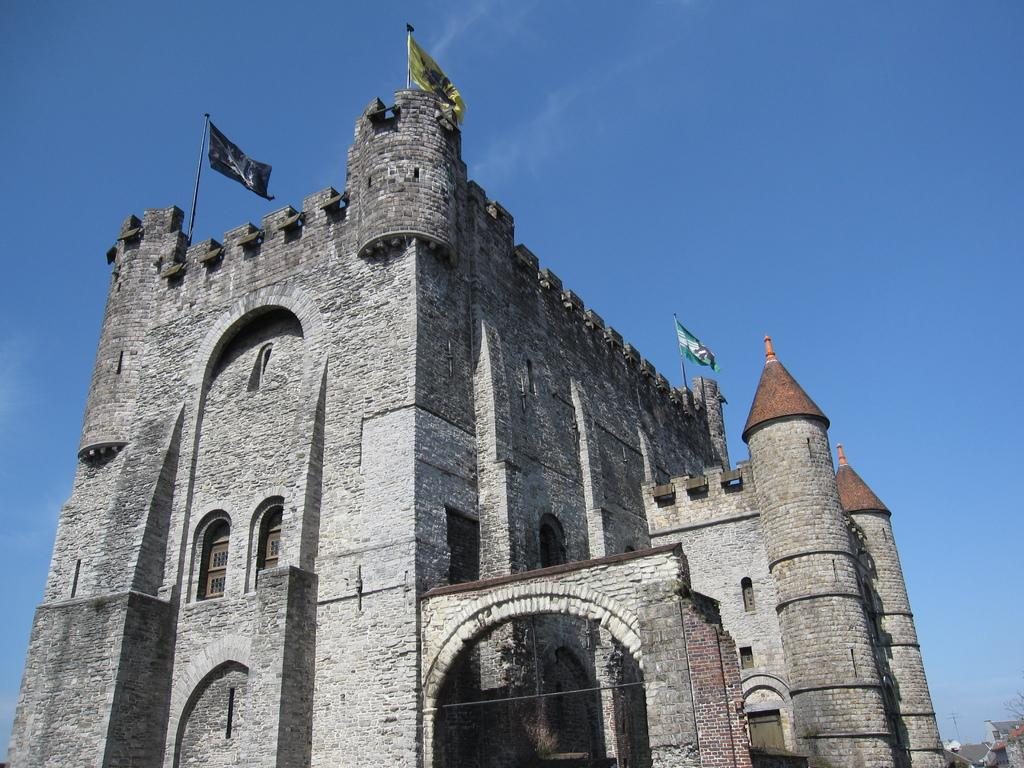What is the main structure visible in the image? There is a building in the image. Are there any additional features on the building? Yes, there are two flags on top of the building. What type of canvas is being used to paint the building in the image? There is no canvas or painting activity present in the image; it is a photograph of a building with flags on top. 